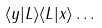Convert formula to latex. <formula><loc_0><loc_0><loc_500><loc_500>\langle y | L \rangle \langle L | x \rangle \dots</formula> 